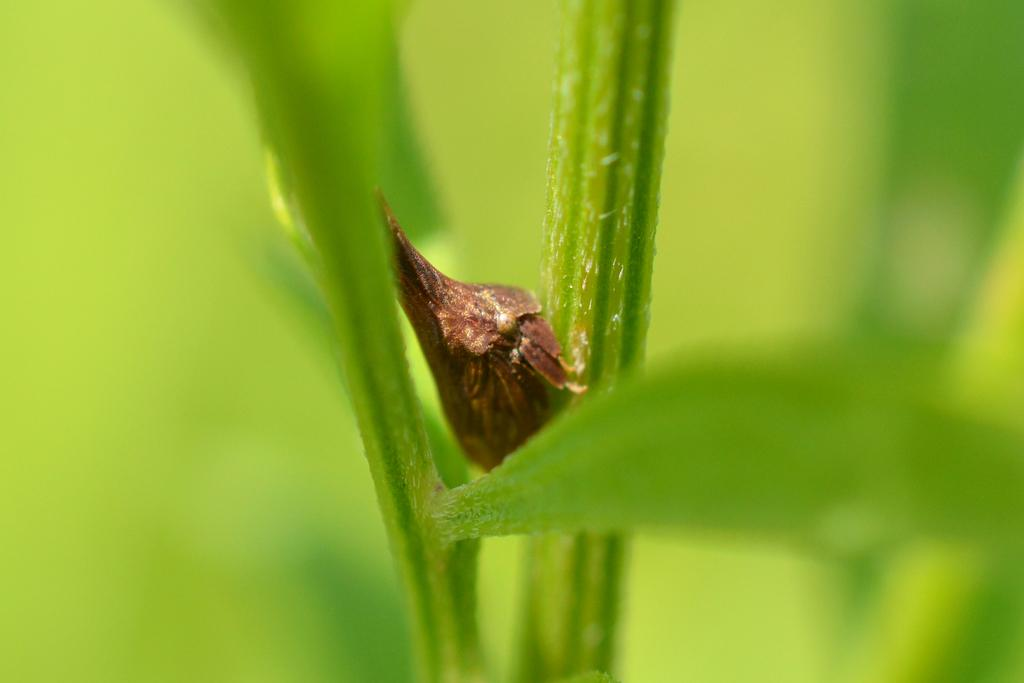What is present on the leaf in the image? There is a bug on the leaf in the image. What is the color of the background in the image? The background of the image is green. What type of net can be seen in the image? There is no net present in the image. What kind of marble is visible in the image? There is no marble present in the image. 